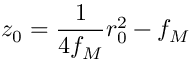<formula> <loc_0><loc_0><loc_500><loc_500>z _ { 0 } = \frac { 1 } { 4 f _ { M } } r _ { 0 } ^ { 2 } - f _ { M }</formula> 